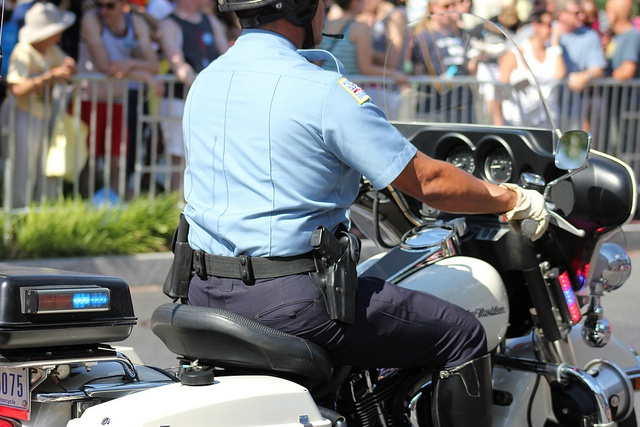Describe the objects in this image and their specific colors. I can see motorcycle in gray, black, white, and darkgray tones, people in gray, lightblue, and black tones, people in gray, darkgray, and ivory tones, people in gray, darkgray, tan, and lightgray tones, and people in gray and maroon tones in this image. 